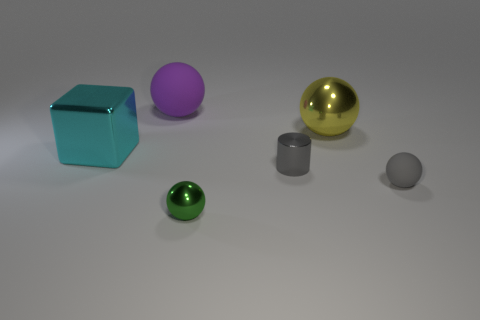Do the rubber object that is right of the tiny green metallic ball and the shiny cylinder have the same color?
Give a very brief answer. Yes. There is a ball that is the same color as the tiny cylinder; what is its material?
Ensure brevity in your answer.  Rubber. Is the size of the gray thing that is left of the gray rubber sphere the same as the tiny gray sphere?
Give a very brief answer. Yes. Are there any tiny matte objects of the same color as the cylinder?
Provide a succinct answer. Yes. There is a large metallic object that is left of the purple object; is there a matte sphere that is in front of it?
Provide a short and direct response. Yes. Is there a tiny cylinder that has the same material as the big cyan block?
Make the answer very short. Yes. What material is the small sphere to the right of the big yellow sphere behind the small gray metallic thing?
Ensure brevity in your answer.  Rubber. There is a object that is on the left side of the green ball and on the right side of the large cyan thing; what is its material?
Provide a short and direct response. Rubber. Are there the same number of yellow shiny things left of the purple sphere and big yellow objects?
Your response must be concise. No. What number of other large things are the same shape as the gray matte thing?
Your answer should be very brief. 2. 